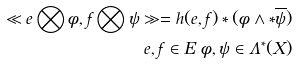<formula> <loc_0><loc_0><loc_500><loc_500>\ll e \bigotimes \phi , f \bigotimes \psi \gg = h ( e , f ) \ast ( \phi \wedge \ast \overline { \psi } ) \\ e , f \in E \text { } \phi , \psi \in \Lambda ^ { \ast } ( X )</formula> 